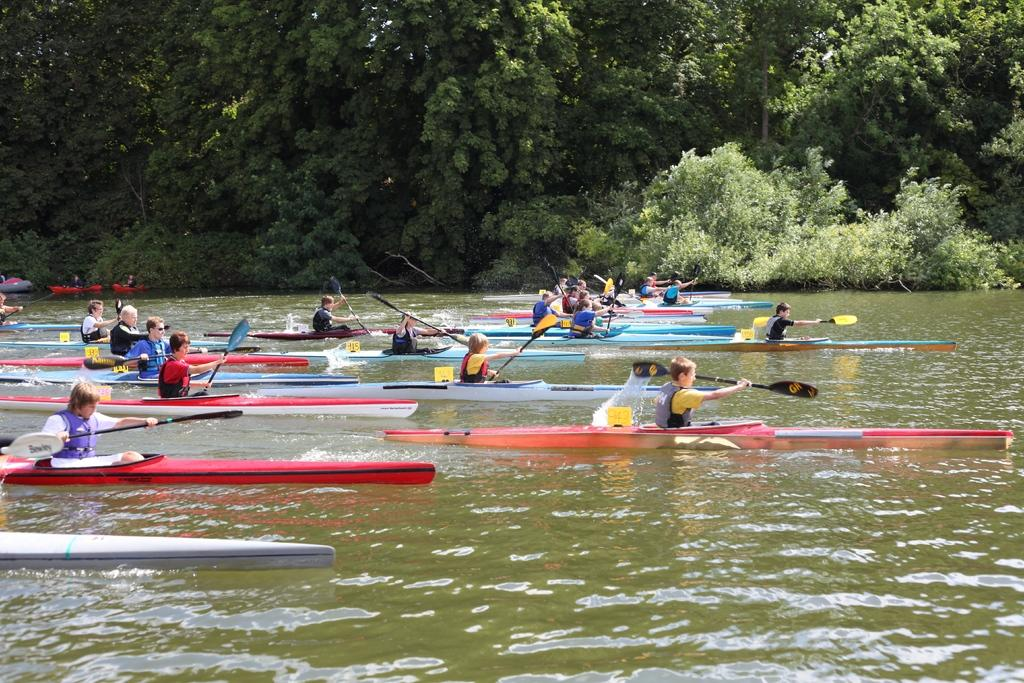What are the people doing in the image? The people are in boats on water. What can be seen in the background of the image? Green trees are visible in the background. What type of pail is being used to catch fish in the image? There is no pail or fishing activity visible in the image; the people are simply in boats on water. 